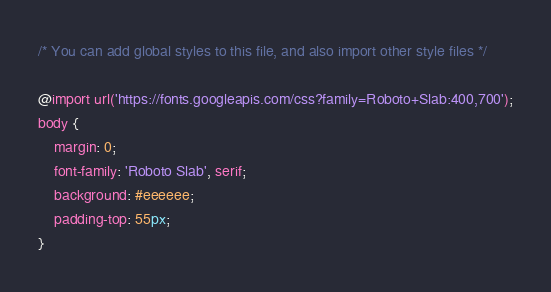<code> <loc_0><loc_0><loc_500><loc_500><_CSS_>/* You can add global styles to this file, and also import other style files */

@import url('https://fonts.googleapis.com/css?family=Roboto+Slab:400,700');
body {
    margin: 0;
    font-family: 'Roboto Slab', serif;
    background: #eeeeee;
    padding-top: 55px;
}</code> 